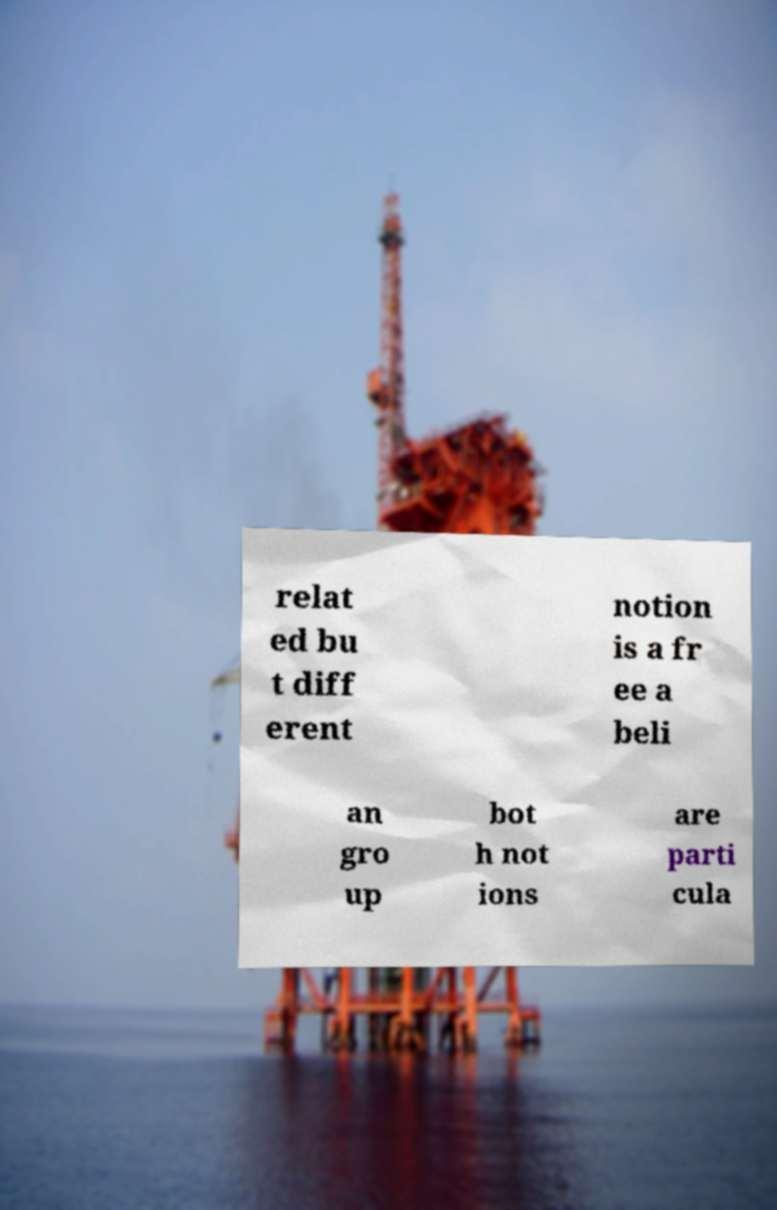Can you accurately transcribe the text from the provided image for me? relat ed bu t diff erent notion is a fr ee a beli an gro up bot h not ions are parti cula 